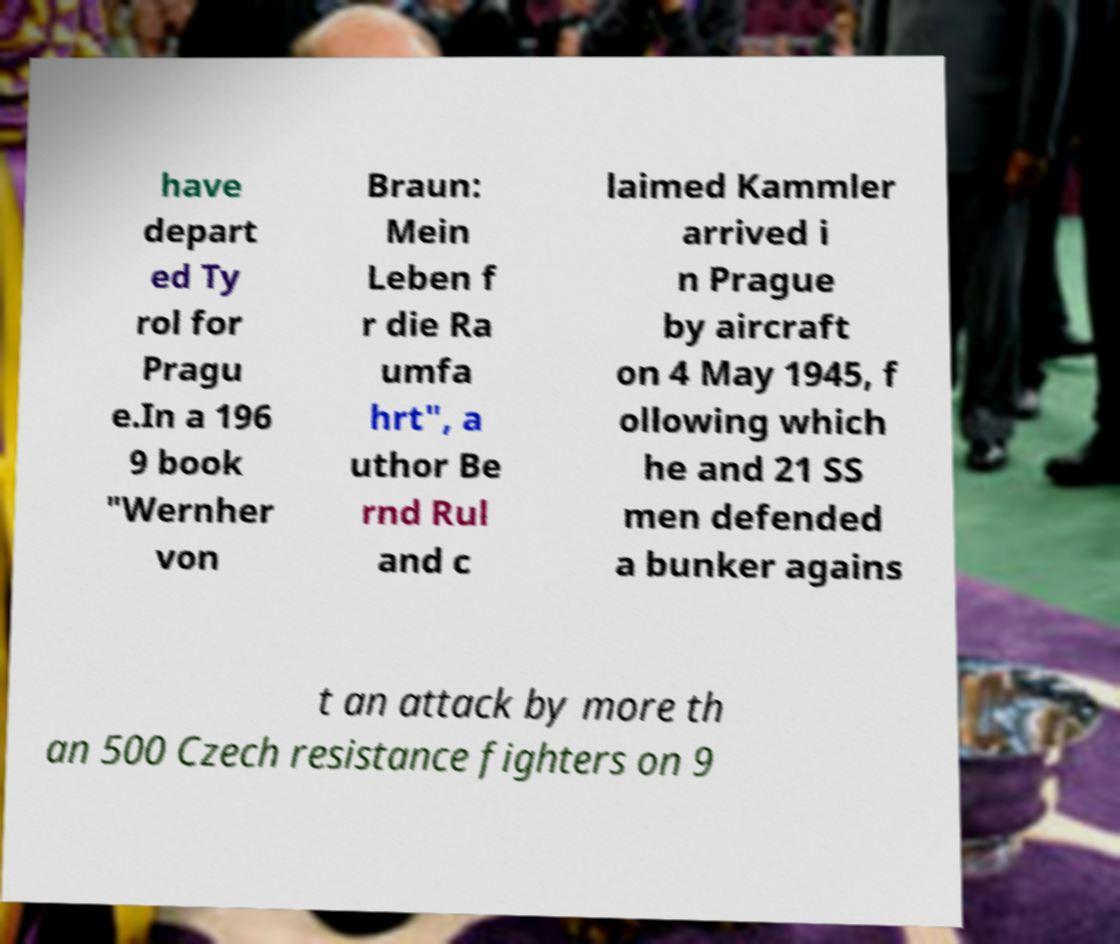Please read and relay the text visible in this image. What does it say? have depart ed Ty rol for Pragu e.In a 196 9 book "Wernher von Braun: Mein Leben f r die Ra umfa hrt", a uthor Be rnd Rul and c laimed Kammler arrived i n Prague by aircraft on 4 May 1945, f ollowing which he and 21 SS men defended a bunker agains t an attack by more th an 500 Czech resistance fighters on 9 